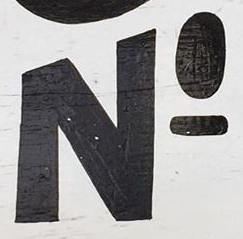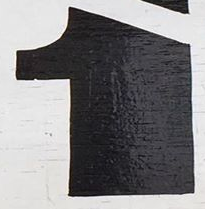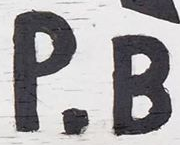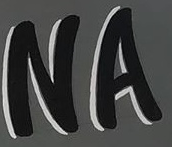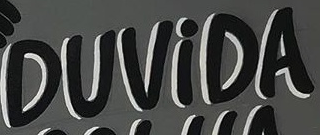Transcribe the words shown in these images in order, separated by a semicolon. NO; 1; P.B; NA; DUViDA 